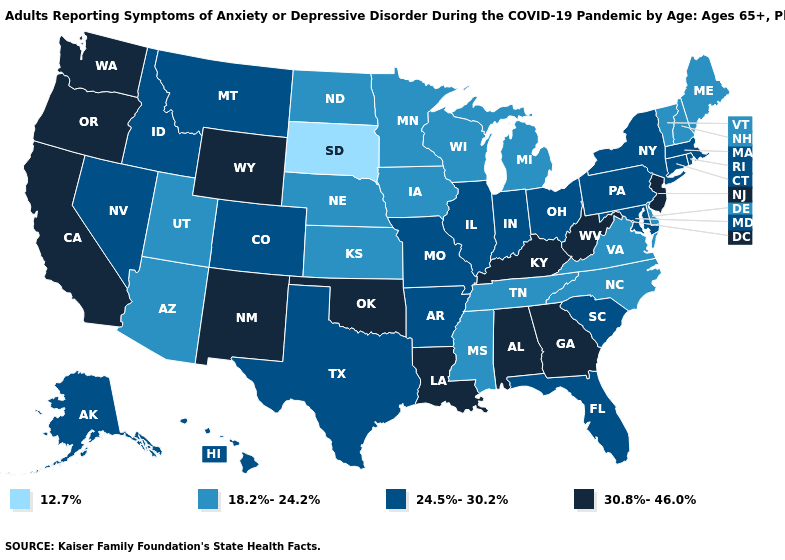What is the lowest value in the USA?
Write a very short answer. 12.7%. What is the lowest value in the MidWest?
Give a very brief answer. 12.7%. Does Virginia have the same value as Utah?
Answer briefly. Yes. What is the lowest value in the USA?
Short answer required. 12.7%. Which states hav the highest value in the South?
Short answer required. Alabama, Georgia, Kentucky, Louisiana, Oklahoma, West Virginia. Does Connecticut have the highest value in the Northeast?
Be succinct. No. What is the lowest value in states that border Colorado?
Short answer required. 18.2%-24.2%. Name the states that have a value in the range 18.2%-24.2%?
Concise answer only. Arizona, Delaware, Iowa, Kansas, Maine, Michigan, Minnesota, Mississippi, Nebraska, New Hampshire, North Carolina, North Dakota, Tennessee, Utah, Vermont, Virginia, Wisconsin. Name the states that have a value in the range 30.8%-46.0%?
Answer briefly. Alabama, California, Georgia, Kentucky, Louisiana, New Jersey, New Mexico, Oklahoma, Oregon, Washington, West Virginia, Wyoming. What is the lowest value in the West?
Be succinct. 18.2%-24.2%. Does the first symbol in the legend represent the smallest category?
Keep it brief. Yes. What is the value of Nevada?
Quick response, please. 24.5%-30.2%. Name the states that have a value in the range 30.8%-46.0%?
Quick response, please. Alabama, California, Georgia, Kentucky, Louisiana, New Jersey, New Mexico, Oklahoma, Oregon, Washington, West Virginia, Wyoming. What is the value of Nevada?
Short answer required. 24.5%-30.2%. 